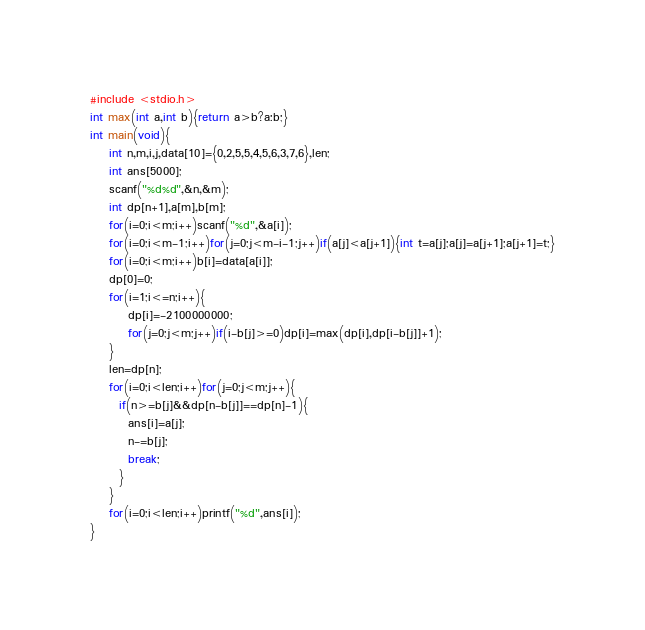<code> <loc_0><loc_0><loc_500><loc_500><_C_>#include <stdio.h>
int max(int a,int b){return a>b?a:b;}
int main(void){
    int n,m,i,j,data[10]={0,2,5,5,4,5,6,3,7,6},len;
    int ans[5000];
    scanf("%d%d",&n,&m);
    int dp[n+1],a[m],b[m];
    for(i=0;i<m;i++)scanf("%d",&a[i]);
    for(i=0;i<m-1;i++)for(j=0;j<m-i-1;j++)if(a[j]<a[j+1]){int t=a[j];a[j]=a[j+1];a[j+1]=t;}
    for(i=0;i<m;i++)b[i]=data[a[i]];
    dp[0]=0;
    for(i=1;i<=n;i++){
        dp[i]=-2100000000;
        for(j=0;j<m;j++)if(i-b[j]>=0)dp[i]=max(dp[i],dp[i-b[j]]+1);
    }
    len=dp[n];
    for(i=0;i<len;i++)for(j=0;j<m;j++){
      if(n>=b[j]&&dp[n-b[j]]==dp[n]-1){
        ans[i]=a[j];
        n-=b[j];
        break;
      }
    }
    for(i=0;i<len;i++)printf("%d",ans[i]);
}</code> 